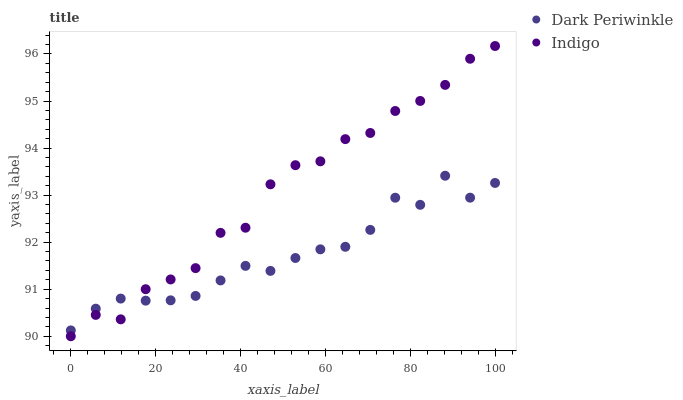Does Dark Periwinkle have the minimum area under the curve?
Answer yes or no. Yes. Does Indigo have the maximum area under the curve?
Answer yes or no. Yes. Does Dark Periwinkle have the maximum area under the curve?
Answer yes or no. No. Is Dark Periwinkle the smoothest?
Answer yes or no. Yes. Is Indigo the roughest?
Answer yes or no. Yes. Is Dark Periwinkle the roughest?
Answer yes or no. No. Does Indigo have the lowest value?
Answer yes or no. Yes. Does Dark Periwinkle have the lowest value?
Answer yes or no. No. Does Indigo have the highest value?
Answer yes or no. Yes. Does Dark Periwinkle have the highest value?
Answer yes or no. No. Does Indigo intersect Dark Periwinkle?
Answer yes or no. Yes. Is Indigo less than Dark Periwinkle?
Answer yes or no. No. Is Indigo greater than Dark Periwinkle?
Answer yes or no. No. 